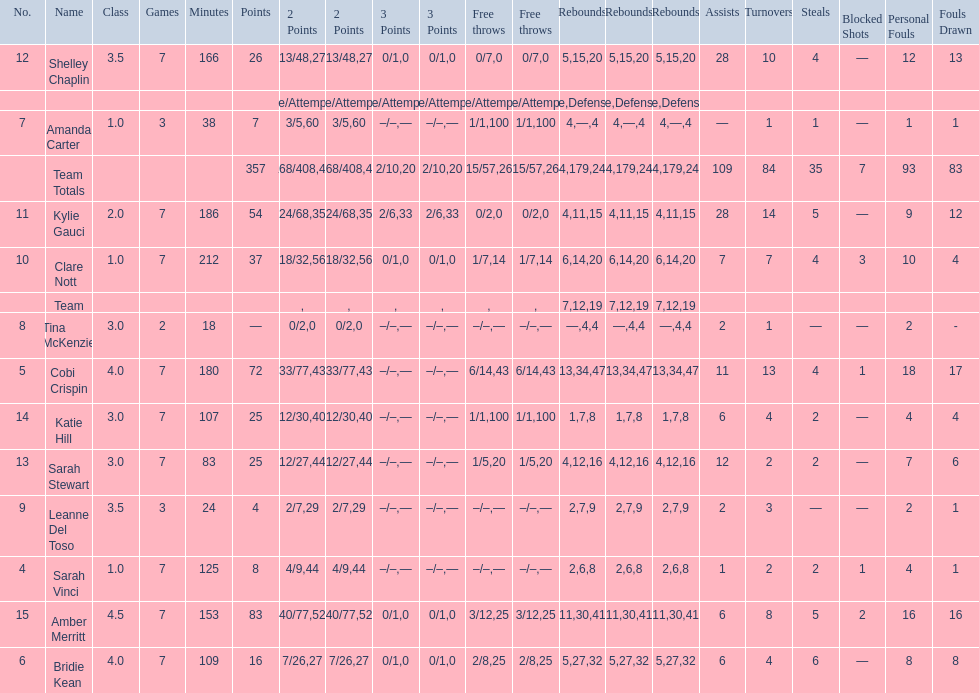Overall count of assists and turnovers 193. 